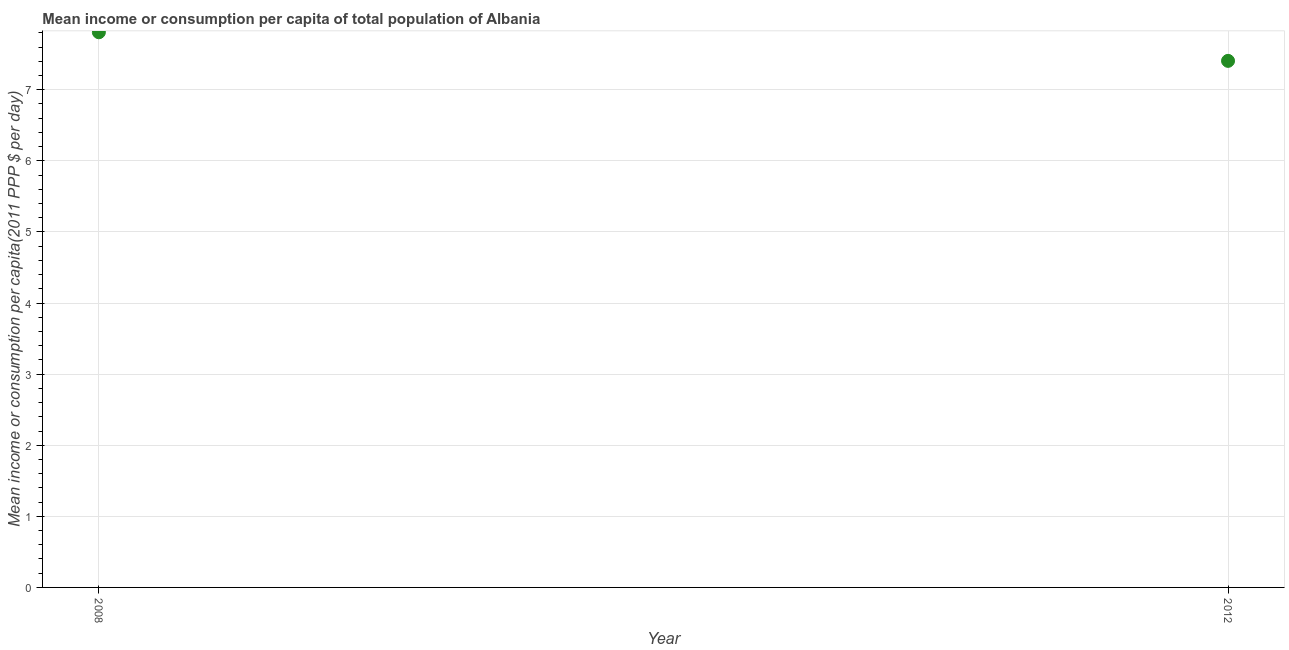What is the mean income or consumption in 2008?
Keep it short and to the point. 7.81. Across all years, what is the maximum mean income or consumption?
Provide a short and direct response. 7.81. Across all years, what is the minimum mean income or consumption?
Make the answer very short. 7.41. In which year was the mean income or consumption maximum?
Your response must be concise. 2008. In which year was the mean income or consumption minimum?
Provide a short and direct response. 2012. What is the sum of the mean income or consumption?
Keep it short and to the point. 15.22. What is the difference between the mean income or consumption in 2008 and 2012?
Offer a terse response. 0.4. What is the average mean income or consumption per year?
Provide a succinct answer. 7.61. What is the median mean income or consumption?
Give a very brief answer. 7.61. In how many years, is the mean income or consumption greater than 5.4 $?
Ensure brevity in your answer.  2. Do a majority of the years between 2012 and 2008 (inclusive) have mean income or consumption greater than 6.6 $?
Provide a succinct answer. No. What is the ratio of the mean income or consumption in 2008 to that in 2012?
Your answer should be compact. 1.05. Is the mean income or consumption in 2008 less than that in 2012?
Give a very brief answer. No. How many years are there in the graph?
Provide a short and direct response. 2. What is the title of the graph?
Ensure brevity in your answer.  Mean income or consumption per capita of total population of Albania. What is the label or title of the Y-axis?
Make the answer very short. Mean income or consumption per capita(2011 PPP $ per day). What is the Mean income or consumption per capita(2011 PPP $ per day) in 2008?
Offer a terse response. 7.81. What is the Mean income or consumption per capita(2011 PPP $ per day) in 2012?
Provide a short and direct response. 7.41. What is the difference between the Mean income or consumption per capita(2011 PPP $ per day) in 2008 and 2012?
Provide a succinct answer. 0.4. What is the ratio of the Mean income or consumption per capita(2011 PPP $ per day) in 2008 to that in 2012?
Provide a short and direct response. 1.05. 